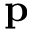Convert formula to latex. <formula><loc_0><loc_0><loc_500><loc_500>p</formula> 